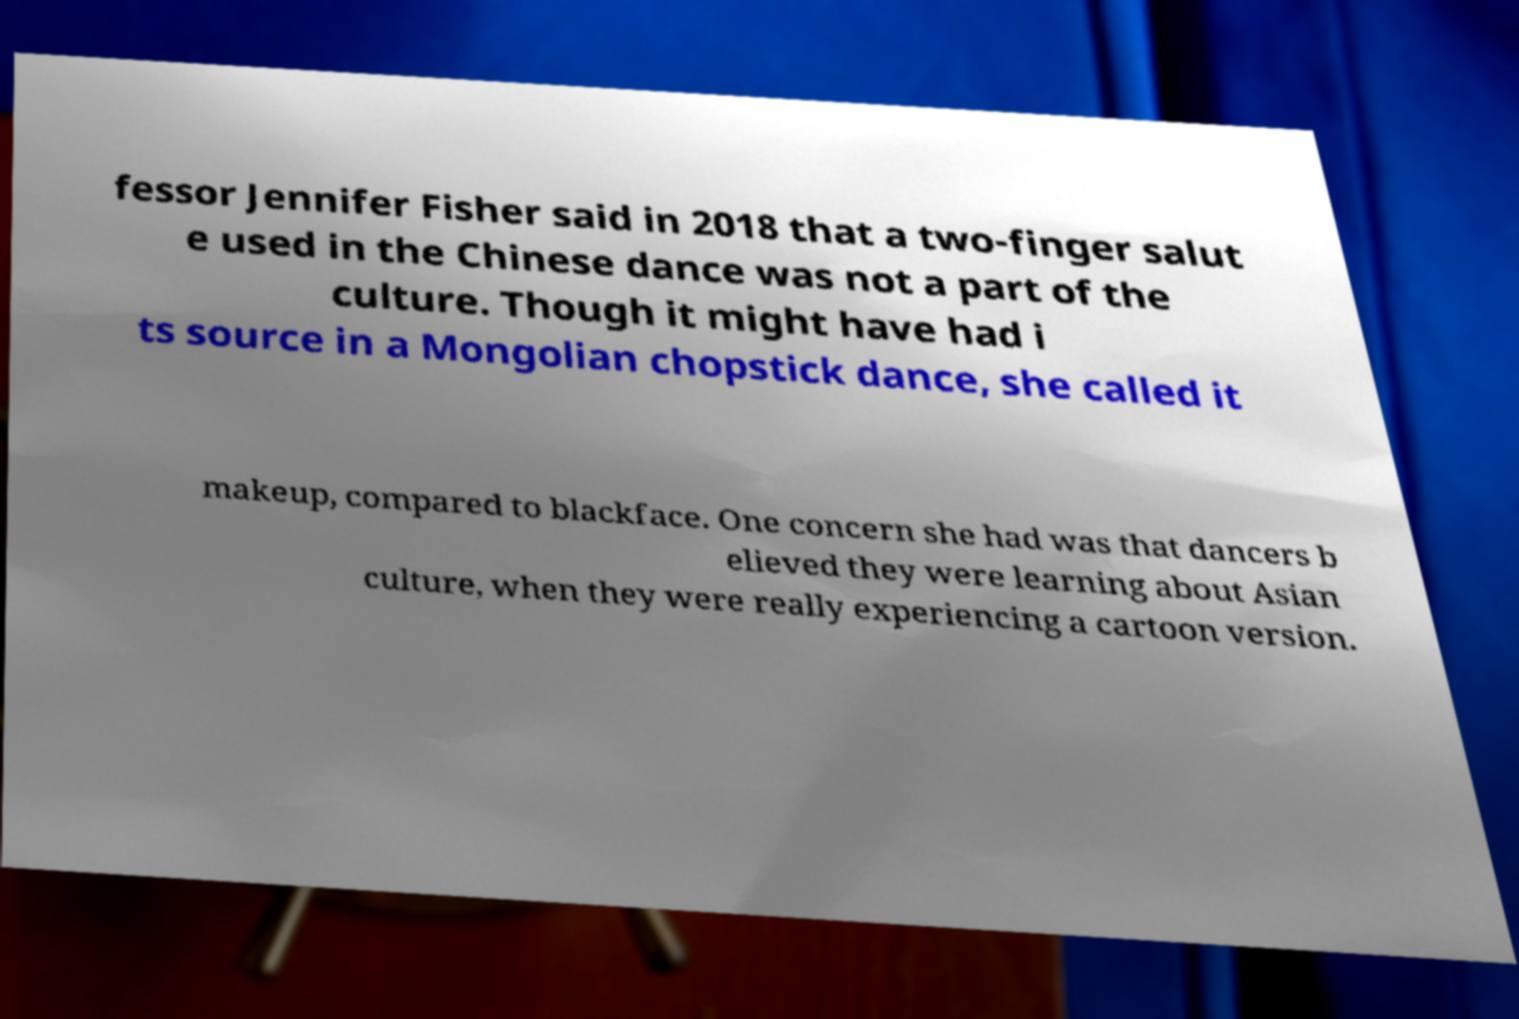For documentation purposes, I need the text within this image transcribed. Could you provide that? fessor Jennifer Fisher said in 2018 that a two-finger salut e used in the Chinese dance was not a part of the culture. Though it might have had i ts source in a Mongolian chopstick dance, she called it makeup, compared to blackface. One concern she had was that dancers b elieved they were learning about Asian culture, when they were really experiencing a cartoon version. 